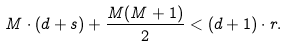<formula> <loc_0><loc_0><loc_500><loc_500>M \cdot ( d + s ) + \frac { M ( M + 1 ) } { 2 } < ( d + 1 ) \cdot r .</formula> 